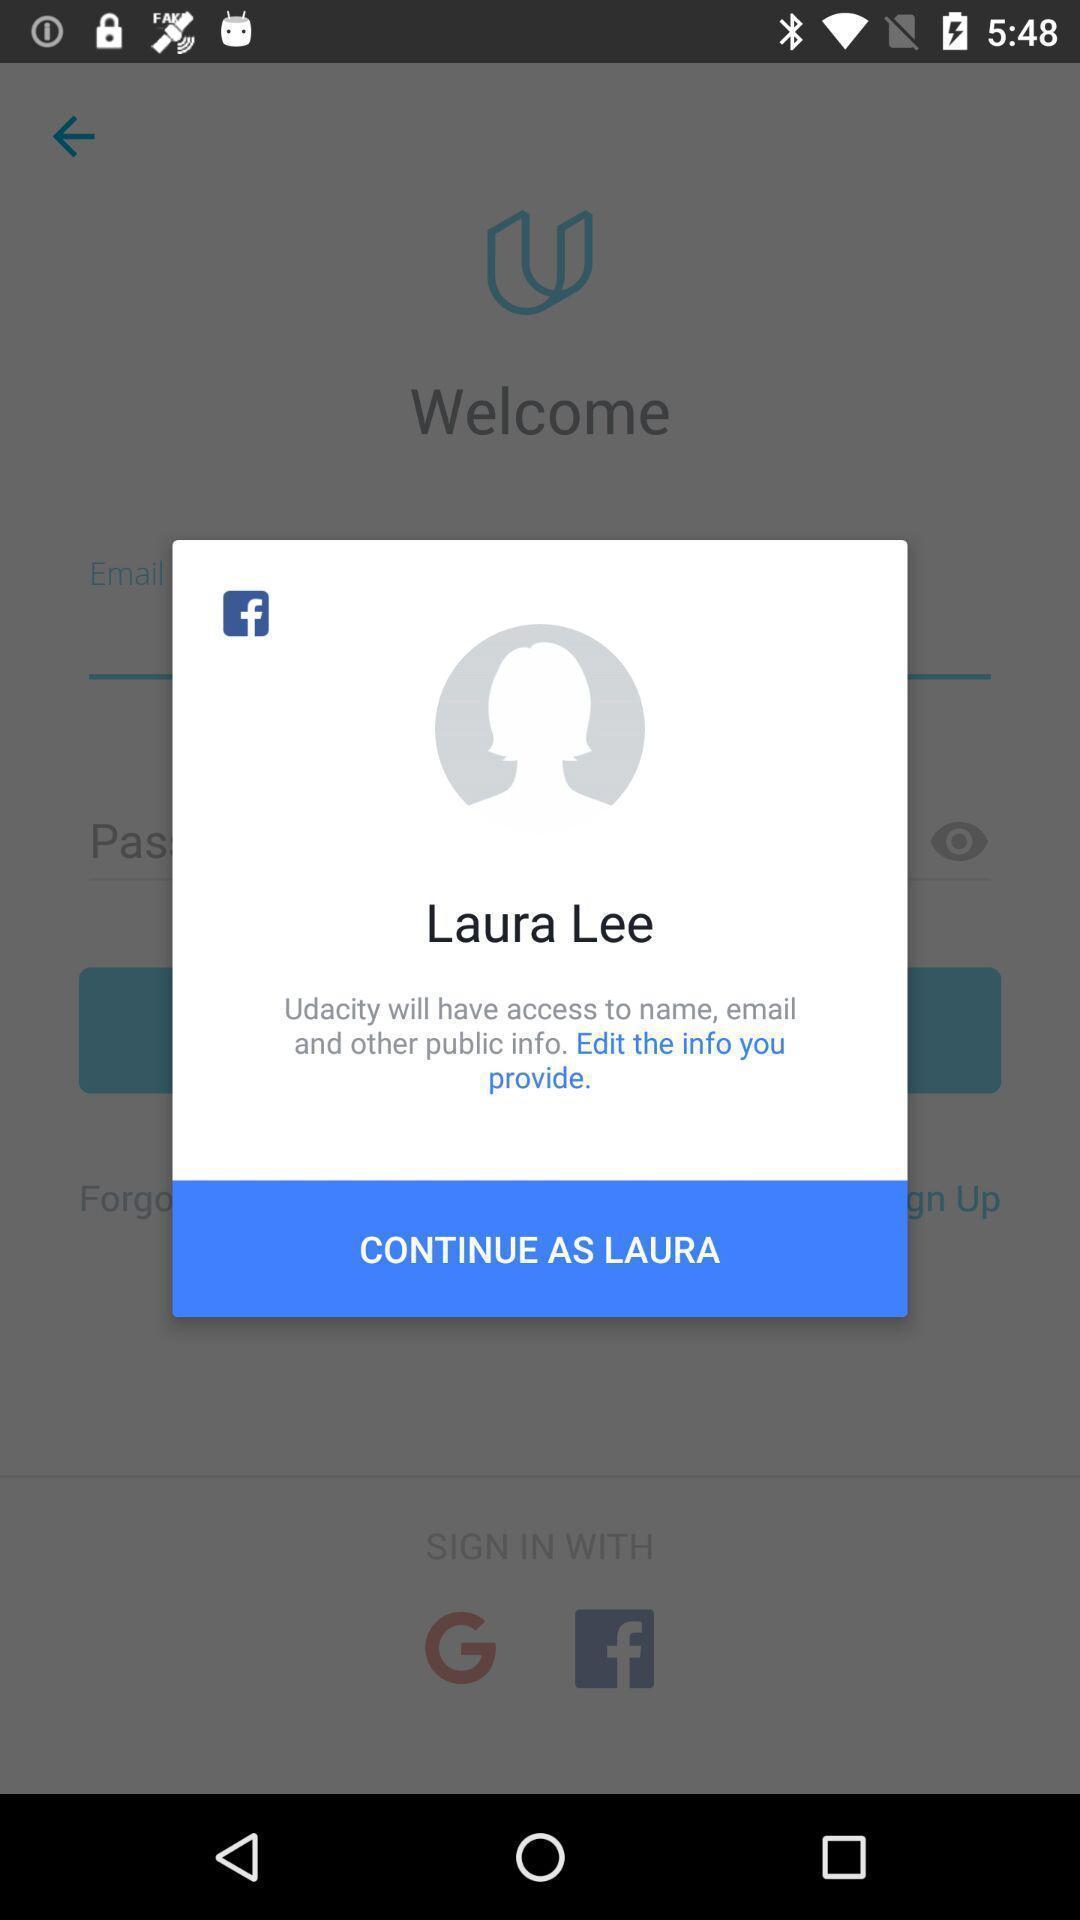Tell me about the visual elements in this screen capture. Pop-up showing profile continuation page of a social app. 